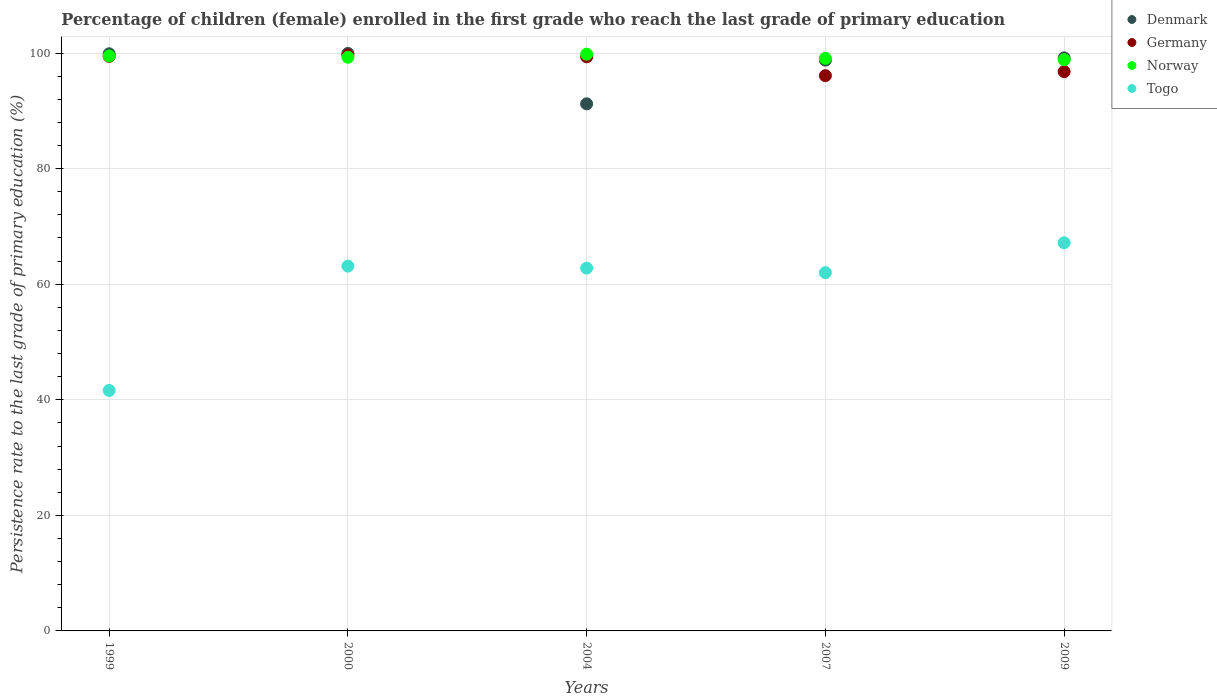What is the persistence rate of children in Germany in 2000?
Your answer should be very brief. 99.68. Across all years, what is the maximum persistence rate of children in Denmark?
Give a very brief answer. 99.94. Across all years, what is the minimum persistence rate of children in Togo?
Your answer should be very brief. 41.62. In which year was the persistence rate of children in Denmark minimum?
Make the answer very short. 2004. What is the total persistence rate of children in Norway in the graph?
Your response must be concise. 496.51. What is the difference between the persistence rate of children in Norway in 2004 and that in 2007?
Your answer should be very brief. 0.72. What is the difference between the persistence rate of children in Germany in 2004 and the persistence rate of children in Denmark in 2007?
Your answer should be very brief. 0.57. What is the average persistence rate of children in Togo per year?
Your response must be concise. 59.34. In the year 2000, what is the difference between the persistence rate of children in Germany and persistence rate of children in Denmark?
Your answer should be very brief. -0.26. What is the ratio of the persistence rate of children in Germany in 1999 to that in 2009?
Keep it short and to the point. 1.03. Is the difference between the persistence rate of children in Germany in 2000 and 2007 greater than the difference between the persistence rate of children in Denmark in 2000 and 2007?
Keep it short and to the point. Yes. What is the difference between the highest and the second highest persistence rate of children in Denmark?
Your answer should be very brief. 0.06. What is the difference between the highest and the lowest persistence rate of children in Norway?
Offer a terse response. 0.95. Is it the case that in every year, the sum of the persistence rate of children in Togo and persistence rate of children in Germany  is greater than the persistence rate of children in Denmark?
Your answer should be very brief. Yes. Does the graph contain any zero values?
Offer a very short reply. No. Where does the legend appear in the graph?
Ensure brevity in your answer.  Top right. How many legend labels are there?
Your answer should be very brief. 4. How are the legend labels stacked?
Your answer should be compact. Vertical. What is the title of the graph?
Offer a very short reply. Percentage of children (female) enrolled in the first grade who reach the last grade of primary education. Does "Uzbekistan" appear as one of the legend labels in the graph?
Make the answer very short. No. What is the label or title of the X-axis?
Offer a very short reply. Years. What is the label or title of the Y-axis?
Ensure brevity in your answer.  Persistence rate to the last grade of primary education (%). What is the Persistence rate to the last grade of primary education (%) in Denmark in 1999?
Provide a succinct answer. 99.88. What is the Persistence rate to the last grade of primary education (%) of Germany in 1999?
Keep it short and to the point. 99.42. What is the Persistence rate to the last grade of primary education (%) in Norway in 1999?
Your answer should be compact. 99.5. What is the Persistence rate to the last grade of primary education (%) in Togo in 1999?
Your answer should be very brief. 41.62. What is the Persistence rate to the last grade of primary education (%) of Denmark in 2000?
Ensure brevity in your answer.  99.94. What is the Persistence rate to the last grade of primary education (%) of Germany in 2000?
Offer a very short reply. 99.68. What is the Persistence rate to the last grade of primary education (%) in Norway in 2000?
Your answer should be compact. 99.27. What is the Persistence rate to the last grade of primary education (%) in Togo in 2000?
Ensure brevity in your answer.  63.13. What is the Persistence rate to the last grade of primary education (%) of Denmark in 2004?
Keep it short and to the point. 91.21. What is the Persistence rate to the last grade of primary education (%) in Germany in 2004?
Offer a terse response. 99.35. What is the Persistence rate to the last grade of primary education (%) in Norway in 2004?
Offer a very short reply. 99.8. What is the Persistence rate to the last grade of primary education (%) of Togo in 2004?
Provide a succinct answer. 62.78. What is the Persistence rate to the last grade of primary education (%) of Denmark in 2007?
Provide a short and direct response. 98.78. What is the Persistence rate to the last grade of primary education (%) in Germany in 2007?
Provide a succinct answer. 96.09. What is the Persistence rate to the last grade of primary education (%) in Norway in 2007?
Make the answer very short. 99.09. What is the Persistence rate to the last grade of primary education (%) of Togo in 2007?
Provide a succinct answer. 62. What is the Persistence rate to the last grade of primary education (%) of Denmark in 2009?
Offer a very short reply. 99.17. What is the Persistence rate to the last grade of primary education (%) in Germany in 2009?
Your answer should be very brief. 96.78. What is the Persistence rate to the last grade of primary education (%) of Norway in 2009?
Offer a terse response. 98.85. What is the Persistence rate to the last grade of primary education (%) of Togo in 2009?
Your answer should be very brief. 67.17. Across all years, what is the maximum Persistence rate to the last grade of primary education (%) of Denmark?
Offer a very short reply. 99.94. Across all years, what is the maximum Persistence rate to the last grade of primary education (%) in Germany?
Offer a terse response. 99.68. Across all years, what is the maximum Persistence rate to the last grade of primary education (%) in Norway?
Ensure brevity in your answer.  99.8. Across all years, what is the maximum Persistence rate to the last grade of primary education (%) in Togo?
Offer a very short reply. 67.17. Across all years, what is the minimum Persistence rate to the last grade of primary education (%) in Denmark?
Offer a terse response. 91.21. Across all years, what is the minimum Persistence rate to the last grade of primary education (%) of Germany?
Your answer should be very brief. 96.09. Across all years, what is the minimum Persistence rate to the last grade of primary education (%) in Norway?
Your answer should be very brief. 98.85. Across all years, what is the minimum Persistence rate to the last grade of primary education (%) in Togo?
Offer a very short reply. 41.62. What is the total Persistence rate to the last grade of primary education (%) of Denmark in the graph?
Your response must be concise. 488.97. What is the total Persistence rate to the last grade of primary education (%) of Germany in the graph?
Give a very brief answer. 491.32. What is the total Persistence rate to the last grade of primary education (%) in Norway in the graph?
Give a very brief answer. 496.51. What is the total Persistence rate to the last grade of primary education (%) in Togo in the graph?
Ensure brevity in your answer.  296.7. What is the difference between the Persistence rate to the last grade of primary education (%) of Denmark in 1999 and that in 2000?
Keep it short and to the point. -0.06. What is the difference between the Persistence rate to the last grade of primary education (%) of Germany in 1999 and that in 2000?
Keep it short and to the point. -0.25. What is the difference between the Persistence rate to the last grade of primary education (%) of Norway in 1999 and that in 2000?
Give a very brief answer. 0.23. What is the difference between the Persistence rate to the last grade of primary education (%) of Togo in 1999 and that in 2000?
Ensure brevity in your answer.  -21.51. What is the difference between the Persistence rate to the last grade of primary education (%) of Denmark in 1999 and that in 2004?
Offer a terse response. 8.66. What is the difference between the Persistence rate to the last grade of primary education (%) of Germany in 1999 and that in 2004?
Keep it short and to the point. 0.08. What is the difference between the Persistence rate to the last grade of primary education (%) of Norway in 1999 and that in 2004?
Ensure brevity in your answer.  -0.3. What is the difference between the Persistence rate to the last grade of primary education (%) of Togo in 1999 and that in 2004?
Give a very brief answer. -21.16. What is the difference between the Persistence rate to the last grade of primary education (%) of Denmark in 1999 and that in 2007?
Give a very brief answer. 1.1. What is the difference between the Persistence rate to the last grade of primary education (%) in Germany in 1999 and that in 2007?
Your answer should be very brief. 3.34. What is the difference between the Persistence rate to the last grade of primary education (%) of Norway in 1999 and that in 2007?
Your answer should be very brief. 0.41. What is the difference between the Persistence rate to the last grade of primary education (%) of Togo in 1999 and that in 2007?
Keep it short and to the point. -20.38. What is the difference between the Persistence rate to the last grade of primary education (%) in Denmark in 1999 and that in 2009?
Ensure brevity in your answer.  0.71. What is the difference between the Persistence rate to the last grade of primary education (%) in Germany in 1999 and that in 2009?
Your answer should be very brief. 2.64. What is the difference between the Persistence rate to the last grade of primary education (%) in Norway in 1999 and that in 2009?
Give a very brief answer. 0.65. What is the difference between the Persistence rate to the last grade of primary education (%) of Togo in 1999 and that in 2009?
Offer a very short reply. -25.55. What is the difference between the Persistence rate to the last grade of primary education (%) of Denmark in 2000 and that in 2004?
Offer a terse response. 8.72. What is the difference between the Persistence rate to the last grade of primary education (%) of Germany in 2000 and that in 2004?
Your answer should be very brief. 0.33. What is the difference between the Persistence rate to the last grade of primary education (%) in Norway in 2000 and that in 2004?
Provide a short and direct response. -0.53. What is the difference between the Persistence rate to the last grade of primary education (%) in Togo in 2000 and that in 2004?
Provide a short and direct response. 0.34. What is the difference between the Persistence rate to the last grade of primary education (%) of Denmark in 2000 and that in 2007?
Provide a succinct answer. 1.16. What is the difference between the Persistence rate to the last grade of primary education (%) of Germany in 2000 and that in 2007?
Provide a short and direct response. 3.59. What is the difference between the Persistence rate to the last grade of primary education (%) in Norway in 2000 and that in 2007?
Give a very brief answer. 0.18. What is the difference between the Persistence rate to the last grade of primary education (%) of Togo in 2000 and that in 2007?
Your answer should be compact. 1.13. What is the difference between the Persistence rate to the last grade of primary education (%) of Denmark in 2000 and that in 2009?
Your response must be concise. 0.77. What is the difference between the Persistence rate to the last grade of primary education (%) in Germany in 2000 and that in 2009?
Offer a very short reply. 2.89. What is the difference between the Persistence rate to the last grade of primary education (%) in Norway in 2000 and that in 2009?
Keep it short and to the point. 0.41. What is the difference between the Persistence rate to the last grade of primary education (%) of Togo in 2000 and that in 2009?
Provide a short and direct response. -4.05. What is the difference between the Persistence rate to the last grade of primary education (%) in Denmark in 2004 and that in 2007?
Keep it short and to the point. -7.56. What is the difference between the Persistence rate to the last grade of primary education (%) of Germany in 2004 and that in 2007?
Offer a terse response. 3.26. What is the difference between the Persistence rate to the last grade of primary education (%) in Norway in 2004 and that in 2007?
Your answer should be compact. 0.72. What is the difference between the Persistence rate to the last grade of primary education (%) in Togo in 2004 and that in 2007?
Ensure brevity in your answer.  0.79. What is the difference between the Persistence rate to the last grade of primary education (%) in Denmark in 2004 and that in 2009?
Your answer should be very brief. -7.95. What is the difference between the Persistence rate to the last grade of primary education (%) of Germany in 2004 and that in 2009?
Your response must be concise. 2.56. What is the difference between the Persistence rate to the last grade of primary education (%) of Norway in 2004 and that in 2009?
Your answer should be very brief. 0.95. What is the difference between the Persistence rate to the last grade of primary education (%) in Togo in 2004 and that in 2009?
Give a very brief answer. -4.39. What is the difference between the Persistence rate to the last grade of primary education (%) of Denmark in 2007 and that in 2009?
Make the answer very short. -0.39. What is the difference between the Persistence rate to the last grade of primary education (%) of Germany in 2007 and that in 2009?
Keep it short and to the point. -0.7. What is the difference between the Persistence rate to the last grade of primary education (%) of Norway in 2007 and that in 2009?
Give a very brief answer. 0.23. What is the difference between the Persistence rate to the last grade of primary education (%) of Togo in 2007 and that in 2009?
Keep it short and to the point. -5.17. What is the difference between the Persistence rate to the last grade of primary education (%) in Denmark in 1999 and the Persistence rate to the last grade of primary education (%) in Germany in 2000?
Your response must be concise. 0.2. What is the difference between the Persistence rate to the last grade of primary education (%) of Denmark in 1999 and the Persistence rate to the last grade of primary education (%) of Norway in 2000?
Provide a succinct answer. 0.61. What is the difference between the Persistence rate to the last grade of primary education (%) in Denmark in 1999 and the Persistence rate to the last grade of primary education (%) in Togo in 2000?
Give a very brief answer. 36.75. What is the difference between the Persistence rate to the last grade of primary education (%) in Germany in 1999 and the Persistence rate to the last grade of primary education (%) in Norway in 2000?
Make the answer very short. 0.15. What is the difference between the Persistence rate to the last grade of primary education (%) in Germany in 1999 and the Persistence rate to the last grade of primary education (%) in Togo in 2000?
Provide a succinct answer. 36.3. What is the difference between the Persistence rate to the last grade of primary education (%) of Norway in 1999 and the Persistence rate to the last grade of primary education (%) of Togo in 2000?
Give a very brief answer. 36.37. What is the difference between the Persistence rate to the last grade of primary education (%) of Denmark in 1999 and the Persistence rate to the last grade of primary education (%) of Germany in 2004?
Your answer should be very brief. 0.53. What is the difference between the Persistence rate to the last grade of primary education (%) in Denmark in 1999 and the Persistence rate to the last grade of primary education (%) in Norway in 2004?
Your answer should be compact. 0.07. What is the difference between the Persistence rate to the last grade of primary education (%) of Denmark in 1999 and the Persistence rate to the last grade of primary education (%) of Togo in 2004?
Keep it short and to the point. 37.09. What is the difference between the Persistence rate to the last grade of primary education (%) in Germany in 1999 and the Persistence rate to the last grade of primary education (%) in Norway in 2004?
Provide a short and direct response. -0.38. What is the difference between the Persistence rate to the last grade of primary education (%) in Germany in 1999 and the Persistence rate to the last grade of primary education (%) in Togo in 2004?
Your response must be concise. 36.64. What is the difference between the Persistence rate to the last grade of primary education (%) of Norway in 1999 and the Persistence rate to the last grade of primary education (%) of Togo in 2004?
Give a very brief answer. 36.72. What is the difference between the Persistence rate to the last grade of primary education (%) of Denmark in 1999 and the Persistence rate to the last grade of primary education (%) of Germany in 2007?
Provide a succinct answer. 3.79. What is the difference between the Persistence rate to the last grade of primary education (%) of Denmark in 1999 and the Persistence rate to the last grade of primary education (%) of Norway in 2007?
Provide a succinct answer. 0.79. What is the difference between the Persistence rate to the last grade of primary education (%) of Denmark in 1999 and the Persistence rate to the last grade of primary education (%) of Togo in 2007?
Make the answer very short. 37.88. What is the difference between the Persistence rate to the last grade of primary education (%) in Germany in 1999 and the Persistence rate to the last grade of primary education (%) in Norway in 2007?
Your answer should be very brief. 0.34. What is the difference between the Persistence rate to the last grade of primary education (%) in Germany in 1999 and the Persistence rate to the last grade of primary education (%) in Togo in 2007?
Your answer should be very brief. 37.43. What is the difference between the Persistence rate to the last grade of primary education (%) of Norway in 1999 and the Persistence rate to the last grade of primary education (%) of Togo in 2007?
Offer a very short reply. 37.5. What is the difference between the Persistence rate to the last grade of primary education (%) of Denmark in 1999 and the Persistence rate to the last grade of primary education (%) of Germany in 2009?
Your response must be concise. 3.09. What is the difference between the Persistence rate to the last grade of primary education (%) in Denmark in 1999 and the Persistence rate to the last grade of primary education (%) in Norway in 2009?
Make the answer very short. 1.02. What is the difference between the Persistence rate to the last grade of primary education (%) of Denmark in 1999 and the Persistence rate to the last grade of primary education (%) of Togo in 2009?
Offer a very short reply. 32.7. What is the difference between the Persistence rate to the last grade of primary education (%) of Germany in 1999 and the Persistence rate to the last grade of primary education (%) of Norway in 2009?
Provide a succinct answer. 0.57. What is the difference between the Persistence rate to the last grade of primary education (%) in Germany in 1999 and the Persistence rate to the last grade of primary education (%) in Togo in 2009?
Your response must be concise. 32.25. What is the difference between the Persistence rate to the last grade of primary education (%) in Norway in 1999 and the Persistence rate to the last grade of primary education (%) in Togo in 2009?
Make the answer very short. 32.33. What is the difference between the Persistence rate to the last grade of primary education (%) in Denmark in 2000 and the Persistence rate to the last grade of primary education (%) in Germany in 2004?
Ensure brevity in your answer.  0.59. What is the difference between the Persistence rate to the last grade of primary education (%) of Denmark in 2000 and the Persistence rate to the last grade of primary education (%) of Norway in 2004?
Keep it short and to the point. 0.13. What is the difference between the Persistence rate to the last grade of primary education (%) of Denmark in 2000 and the Persistence rate to the last grade of primary education (%) of Togo in 2004?
Keep it short and to the point. 37.15. What is the difference between the Persistence rate to the last grade of primary education (%) in Germany in 2000 and the Persistence rate to the last grade of primary education (%) in Norway in 2004?
Provide a succinct answer. -0.13. What is the difference between the Persistence rate to the last grade of primary education (%) of Germany in 2000 and the Persistence rate to the last grade of primary education (%) of Togo in 2004?
Your response must be concise. 36.89. What is the difference between the Persistence rate to the last grade of primary education (%) in Norway in 2000 and the Persistence rate to the last grade of primary education (%) in Togo in 2004?
Give a very brief answer. 36.49. What is the difference between the Persistence rate to the last grade of primary education (%) of Denmark in 2000 and the Persistence rate to the last grade of primary education (%) of Germany in 2007?
Keep it short and to the point. 3.85. What is the difference between the Persistence rate to the last grade of primary education (%) of Denmark in 2000 and the Persistence rate to the last grade of primary education (%) of Norway in 2007?
Offer a terse response. 0.85. What is the difference between the Persistence rate to the last grade of primary education (%) in Denmark in 2000 and the Persistence rate to the last grade of primary education (%) in Togo in 2007?
Offer a very short reply. 37.94. What is the difference between the Persistence rate to the last grade of primary education (%) in Germany in 2000 and the Persistence rate to the last grade of primary education (%) in Norway in 2007?
Provide a short and direct response. 0.59. What is the difference between the Persistence rate to the last grade of primary education (%) in Germany in 2000 and the Persistence rate to the last grade of primary education (%) in Togo in 2007?
Give a very brief answer. 37.68. What is the difference between the Persistence rate to the last grade of primary education (%) of Norway in 2000 and the Persistence rate to the last grade of primary education (%) of Togo in 2007?
Provide a short and direct response. 37.27. What is the difference between the Persistence rate to the last grade of primary education (%) in Denmark in 2000 and the Persistence rate to the last grade of primary education (%) in Germany in 2009?
Make the answer very short. 3.15. What is the difference between the Persistence rate to the last grade of primary education (%) of Denmark in 2000 and the Persistence rate to the last grade of primary education (%) of Norway in 2009?
Provide a short and direct response. 1.08. What is the difference between the Persistence rate to the last grade of primary education (%) of Denmark in 2000 and the Persistence rate to the last grade of primary education (%) of Togo in 2009?
Ensure brevity in your answer.  32.76. What is the difference between the Persistence rate to the last grade of primary education (%) of Germany in 2000 and the Persistence rate to the last grade of primary education (%) of Norway in 2009?
Your answer should be compact. 0.82. What is the difference between the Persistence rate to the last grade of primary education (%) of Germany in 2000 and the Persistence rate to the last grade of primary education (%) of Togo in 2009?
Make the answer very short. 32.51. What is the difference between the Persistence rate to the last grade of primary education (%) in Norway in 2000 and the Persistence rate to the last grade of primary education (%) in Togo in 2009?
Make the answer very short. 32.1. What is the difference between the Persistence rate to the last grade of primary education (%) in Denmark in 2004 and the Persistence rate to the last grade of primary education (%) in Germany in 2007?
Ensure brevity in your answer.  -4.87. What is the difference between the Persistence rate to the last grade of primary education (%) in Denmark in 2004 and the Persistence rate to the last grade of primary education (%) in Norway in 2007?
Provide a short and direct response. -7.87. What is the difference between the Persistence rate to the last grade of primary education (%) in Denmark in 2004 and the Persistence rate to the last grade of primary education (%) in Togo in 2007?
Ensure brevity in your answer.  29.22. What is the difference between the Persistence rate to the last grade of primary education (%) of Germany in 2004 and the Persistence rate to the last grade of primary education (%) of Norway in 2007?
Provide a succinct answer. 0.26. What is the difference between the Persistence rate to the last grade of primary education (%) in Germany in 2004 and the Persistence rate to the last grade of primary education (%) in Togo in 2007?
Offer a very short reply. 37.35. What is the difference between the Persistence rate to the last grade of primary education (%) in Norway in 2004 and the Persistence rate to the last grade of primary education (%) in Togo in 2007?
Your answer should be very brief. 37.81. What is the difference between the Persistence rate to the last grade of primary education (%) of Denmark in 2004 and the Persistence rate to the last grade of primary education (%) of Germany in 2009?
Keep it short and to the point. -5.57. What is the difference between the Persistence rate to the last grade of primary education (%) in Denmark in 2004 and the Persistence rate to the last grade of primary education (%) in Norway in 2009?
Offer a terse response. -7.64. What is the difference between the Persistence rate to the last grade of primary education (%) of Denmark in 2004 and the Persistence rate to the last grade of primary education (%) of Togo in 2009?
Give a very brief answer. 24.04. What is the difference between the Persistence rate to the last grade of primary education (%) of Germany in 2004 and the Persistence rate to the last grade of primary education (%) of Norway in 2009?
Offer a terse response. 0.49. What is the difference between the Persistence rate to the last grade of primary education (%) in Germany in 2004 and the Persistence rate to the last grade of primary education (%) in Togo in 2009?
Keep it short and to the point. 32.18. What is the difference between the Persistence rate to the last grade of primary education (%) of Norway in 2004 and the Persistence rate to the last grade of primary education (%) of Togo in 2009?
Offer a terse response. 32.63. What is the difference between the Persistence rate to the last grade of primary education (%) in Denmark in 2007 and the Persistence rate to the last grade of primary education (%) in Germany in 2009?
Your answer should be very brief. 1.99. What is the difference between the Persistence rate to the last grade of primary education (%) of Denmark in 2007 and the Persistence rate to the last grade of primary education (%) of Norway in 2009?
Provide a short and direct response. -0.08. What is the difference between the Persistence rate to the last grade of primary education (%) of Denmark in 2007 and the Persistence rate to the last grade of primary education (%) of Togo in 2009?
Your answer should be very brief. 31.6. What is the difference between the Persistence rate to the last grade of primary education (%) in Germany in 2007 and the Persistence rate to the last grade of primary education (%) in Norway in 2009?
Offer a very short reply. -2.77. What is the difference between the Persistence rate to the last grade of primary education (%) in Germany in 2007 and the Persistence rate to the last grade of primary education (%) in Togo in 2009?
Offer a very short reply. 28.92. What is the difference between the Persistence rate to the last grade of primary education (%) of Norway in 2007 and the Persistence rate to the last grade of primary education (%) of Togo in 2009?
Offer a very short reply. 31.91. What is the average Persistence rate to the last grade of primary education (%) of Denmark per year?
Keep it short and to the point. 97.79. What is the average Persistence rate to the last grade of primary education (%) in Germany per year?
Keep it short and to the point. 98.26. What is the average Persistence rate to the last grade of primary education (%) in Norway per year?
Ensure brevity in your answer.  99.3. What is the average Persistence rate to the last grade of primary education (%) of Togo per year?
Offer a terse response. 59.34. In the year 1999, what is the difference between the Persistence rate to the last grade of primary education (%) of Denmark and Persistence rate to the last grade of primary education (%) of Germany?
Give a very brief answer. 0.45. In the year 1999, what is the difference between the Persistence rate to the last grade of primary education (%) of Denmark and Persistence rate to the last grade of primary education (%) of Norway?
Provide a short and direct response. 0.38. In the year 1999, what is the difference between the Persistence rate to the last grade of primary education (%) in Denmark and Persistence rate to the last grade of primary education (%) in Togo?
Keep it short and to the point. 58.26. In the year 1999, what is the difference between the Persistence rate to the last grade of primary education (%) of Germany and Persistence rate to the last grade of primary education (%) of Norway?
Your answer should be compact. -0.08. In the year 1999, what is the difference between the Persistence rate to the last grade of primary education (%) of Germany and Persistence rate to the last grade of primary education (%) of Togo?
Your response must be concise. 57.8. In the year 1999, what is the difference between the Persistence rate to the last grade of primary education (%) of Norway and Persistence rate to the last grade of primary education (%) of Togo?
Keep it short and to the point. 57.88. In the year 2000, what is the difference between the Persistence rate to the last grade of primary education (%) in Denmark and Persistence rate to the last grade of primary education (%) in Germany?
Provide a short and direct response. 0.26. In the year 2000, what is the difference between the Persistence rate to the last grade of primary education (%) of Denmark and Persistence rate to the last grade of primary education (%) of Norway?
Provide a succinct answer. 0.67. In the year 2000, what is the difference between the Persistence rate to the last grade of primary education (%) in Denmark and Persistence rate to the last grade of primary education (%) in Togo?
Ensure brevity in your answer.  36.81. In the year 2000, what is the difference between the Persistence rate to the last grade of primary education (%) of Germany and Persistence rate to the last grade of primary education (%) of Norway?
Keep it short and to the point. 0.41. In the year 2000, what is the difference between the Persistence rate to the last grade of primary education (%) of Germany and Persistence rate to the last grade of primary education (%) of Togo?
Provide a succinct answer. 36.55. In the year 2000, what is the difference between the Persistence rate to the last grade of primary education (%) of Norway and Persistence rate to the last grade of primary education (%) of Togo?
Give a very brief answer. 36.14. In the year 2004, what is the difference between the Persistence rate to the last grade of primary education (%) of Denmark and Persistence rate to the last grade of primary education (%) of Germany?
Make the answer very short. -8.13. In the year 2004, what is the difference between the Persistence rate to the last grade of primary education (%) of Denmark and Persistence rate to the last grade of primary education (%) of Norway?
Ensure brevity in your answer.  -8.59. In the year 2004, what is the difference between the Persistence rate to the last grade of primary education (%) in Denmark and Persistence rate to the last grade of primary education (%) in Togo?
Give a very brief answer. 28.43. In the year 2004, what is the difference between the Persistence rate to the last grade of primary education (%) in Germany and Persistence rate to the last grade of primary education (%) in Norway?
Offer a very short reply. -0.46. In the year 2004, what is the difference between the Persistence rate to the last grade of primary education (%) of Germany and Persistence rate to the last grade of primary education (%) of Togo?
Your answer should be very brief. 36.56. In the year 2004, what is the difference between the Persistence rate to the last grade of primary education (%) of Norway and Persistence rate to the last grade of primary education (%) of Togo?
Give a very brief answer. 37.02. In the year 2007, what is the difference between the Persistence rate to the last grade of primary education (%) of Denmark and Persistence rate to the last grade of primary education (%) of Germany?
Your answer should be very brief. 2.69. In the year 2007, what is the difference between the Persistence rate to the last grade of primary education (%) of Denmark and Persistence rate to the last grade of primary education (%) of Norway?
Your response must be concise. -0.31. In the year 2007, what is the difference between the Persistence rate to the last grade of primary education (%) of Denmark and Persistence rate to the last grade of primary education (%) of Togo?
Offer a terse response. 36.78. In the year 2007, what is the difference between the Persistence rate to the last grade of primary education (%) of Germany and Persistence rate to the last grade of primary education (%) of Norway?
Ensure brevity in your answer.  -3. In the year 2007, what is the difference between the Persistence rate to the last grade of primary education (%) in Germany and Persistence rate to the last grade of primary education (%) in Togo?
Give a very brief answer. 34.09. In the year 2007, what is the difference between the Persistence rate to the last grade of primary education (%) of Norway and Persistence rate to the last grade of primary education (%) of Togo?
Your response must be concise. 37.09. In the year 2009, what is the difference between the Persistence rate to the last grade of primary education (%) of Denmark and Persistence rate to the last grade of primary education (%) of Germany?
Your answer should be very brief. 2.38. In the year 2009, what is the difference between the Persistence rate to the last grade of primary education (%) of Denmark and Persistence rate to the last grade of primary education (%) of Norway?
Keep it short and to the point. 0.31. In the year 2009, what is the difference between the Persistence rate to the last grade of primary education (%) of Denmark and Persistence rate to the last grade of primary education (%) of Togo?
Ensure brevity in your answer.  32. In the year 2009, what is the difference between the Persistence rate to the last grade of primary education (%) of Germany and Persistence rate to the last grade of primary education (%) of Norway?
Provide a succinct answer. -2.07. In the year 2009, what is the difference between the Persistence rate to the last grade of primary education (%) in Germany and Persistence rate to the last grade of primary education (%) in Togo?
Provide a short and direct response. 29.61. In the year 2009, what is the difference between the Persistence rate to the last grade of primary education (%) of Norway and Persistence rate to the last grade of primary education (%) of Togo?
Provide a succinct answer. 31.68. What is the ratio of the Persistence rate to the last grade of primary education (%) of Germany in 1999 to that in 2000?
Your answer should be very brief. 1. What is the ratio of the Persistence rate to the last grade of primary education (%) in Togo in 1999 to that in 2000?
Provide a succinct answer. 0.66. What is the ratio of the Persistence rate to the last grade of primary education (%) in Denmark in 1999 to that in 2004?
Give a very brief answer. 1.09. What is the ratio of the Persistence rate to the last grade of primary education (%) in Germany in 1999 to that in 2004?
Offer a very short reply. 1. What is the ratio of the Persistence rate to the last grade of primary education (%) in Togo in 1999 to that in 2004?
Your answer should be very brief. 0.66. What is the ratio of the Persistence rate to the last grade of primary education (%) of Denmark in 1999 to that in 2007?
Keep it short and to the point. 1.01. What is the ratio of the Persistence rate to the last grade of primary education (%) in Germany in 1999 to that in 2007?
Ensure brevity in your answer.  1.03. What is the ratio of the Persistence rate to the last grade of primary education (%) in Norway in 1999 to that in 2007?
Offer a very short reply. 1. What is the ratio of the Persistence rate to the last grade of primary education (%) of Togo in 1999 to that in 2007?
Your answer should be very brief. 0.67. What is the ratio of the Persistence rate to the last grade of primary education (%) of Denmark in 1999 to that in 2009?
Ensure brevity in your answer.  1.01. What is the ratio of the Persistence rate to the last grade of primary education (%) in Germany in 1999 to that in 2009?
Your response must be concise. 1.03. What is the ratio of the Persistence rate to the last grade of primary education (%) in Norway in 1999 to that in 2009?
Ensure brevity in your answer.  1.01. What is the ratio of the Persistence rate to the last grade of primary education (%) of Togo in 1999 to that in 2009?
Give a very brief answer. 0.62. What is the ratio of the Persistence rate to the last grade of primary education (%) of Denmark in 2000 to that in 2004?
Your answer should be compact. 1.1. What is the ratio of the Persistence rate to the last grade of primary education (%) in Norway in 2000 to that in 2004?
Make the answer very short. 0.99. What is the ratio of the Persistence rate to the last grade of primary education (%) in Togo in 2000 to that in 2004?
Offer a terse response. 1.01. What is the ratio of the Persistence rate to the last grade of primary education (%) in Denmark in 2000 to that in 2007?
Offer a very short reply. 1.01. What is the ratio of the Persistence rate to the last grade of primary education (%) of Germany in 2000 to that in 2007?
Make the answer very short. 1.04. What is the ratio of the Persistence rate to the last grade of primary education (%) of Norway in 2000 to that in 2007?
Your answer should be very brief. 1. What is the ratio of the Persistence rate to the last grade of primary education (%) of Togo in 2000 to that in 2007?
Make the answer very short. 1.02. What is the ratio of the Persistence rate to the last grade of primary education (%) in Denmark in 2000 to that in 2009?
Give a very brief answer. 1.01. What is the ratio of the Persistence rate to the last grade of primary education (%) of Germany in 2000 to that in 2009?
Provide a succinct answer. 1.03. What is the ratio of the Persistence rate to the last grade of primary education (%) in Togo in 2000 to that in 2009?
Offer a terse response. 0.94. What is the ratio of the Persistence rate to the last grade of primary education (%) of Denmark in 2004 to that in 2007?
Keep it short and to the point. 0.92. What is the ratio of the Persistence rate to the last grade of primary education (%) of Germany in 2004 to that in 2007?
Your response must be concise. 1.03. What is the ratio of the Persistence rate to the last grade of primary education (%) of Norway in 2004 to that in 2007?
Ensure brevity in your answer.  1.01. What is the ratio of the Persistence rate to the last grade of primary education (%) in Togo in 2004 to that in 2007?
Your answer should be very brief. 1.01. What is the ratio of the Persistence rate to the last grade of primary education (%) in Denmark in 2004 to that in 2009?
Your answer should be very brief. 0.92. What is the ratio of the Persistence rate to the last grade of primary education (%) in Germany in 2004 to that in 2009?
Your answer should be very brief. 1.03. What is the ratio of the Persistence rate to the last grade of primary education (%) in Norway in 2004 to that in 2009?
Your answer should be compact. 1.01. What is the ratio of the Persistence rate to the last grade of primary education (%) of Togo in 2004 to that in 2009?
Your response must be concise. 0.93. What is the ratio of the Persistence rate to the last grade of primary education (%) of Norway in 2007 to that in 2009?
Your response must be concise. 1. What is the ratio of the Persistence rate to the last grade of primary education (%) in Togo in 2007 to that in 2009?
Your answer should be very brief. 0.92. What is the difference between the highest and the second highest Persistence rate to the last grade of primary education (%) in Denmark?
Your response must be concise. 0.06. What is the difference between the highest and the second highest Persistence rate to the last grade of primary education (%) in Germany?
Ensure brevity in your answer.  0.25. What is the difference between the highest and the second highest Persistence rate to the last grade of primary education (%) of Norway?
Ensure brevity in your answer.  0.3. What is the difference between the highest and the second highest Persistence rate to the last grade of primary education (%) of Togo?
Give a very brief answer. 4.05. What is the difference between the highest and the lowest Persistence rate to the last grade of primary education (%) of Denmark?
Ensure brevity in your answer.  8.72. What is the difference between the highest and the lowest Persistence rate to the last grade of primary education (%) in Germany?
Ensure brevity in your answer.  3.59. What is the difference between the highest and the lowest Persistence rate to the last grade of primary education (%) of Norway?
Provide a short and direct response. 0.95. What is the difference between the highest and the lowest Persistence rate to the last grade of primary education (%) of Togo?
Your response must be concise. 25.55. 